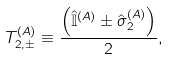Convert formula to latex. <formula><loc_0><loc_0><loc_500><loc_500>T ^ { ( A ) } _ { 2 , \pm } \equiv \frac { \left ( { \hat { \mathbb { I } } } ^ { ( A ) } \pm { \hat { \sigma } } ^ { ( A ) } _ { 2 } \right ) } { 2 } ,</formula> 